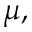<formula> <loc_0><loc_0><loc_500><loc_500>\mu ,</formula> 